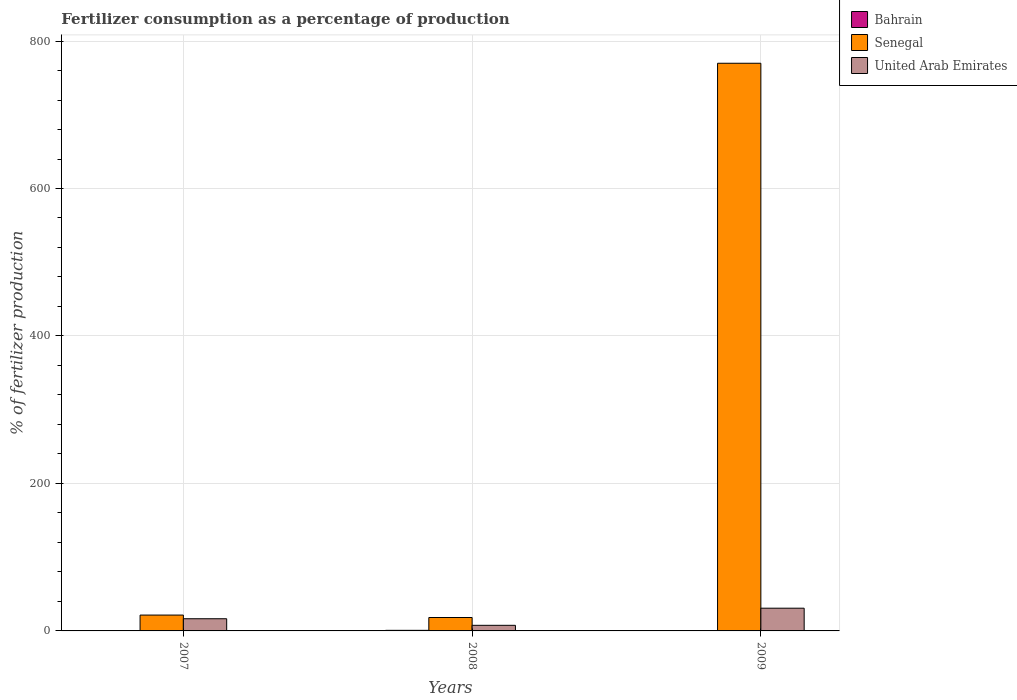Are the number of bars on each tick of the X-axis equal?
Your answer should be compact. Yes. How many bars are there on the 3rd tick from the left?
Your answer should be compact. 3. What is the label of the 2nd group of bars from the left?
Keep it short and to the point. 2008. In how many cases, is the number of bars for a given year not equal to the number of legend labels?
Offer a very short reply. 0. What is the percentage of fertilizers consumed in Senegal in 2009?
Ensure brevity in your answer.  769.84. Across all years, what is the maximum percentage of fertilizers consumed in Bahrain?
Your answer should be very brief. 0.79. Across all years, what is the minimum percentage of fertilizers consumed in Bahrain?
Your answer should be very brief. 0.42. In which year was the percentage of fertilizers consumed in Bahrain maximum?
Your answer should be compact. 2008. In which year was the percentage of fertilizers consumed in United Arab Emirates minimum?
Provide a short and direct response. 2008. What is the total percentage of fertilizers consumed in United Arab Emirates in the graph?
Keep it short and to the point. 54.95. What is the difference between the percentage of fertilizers consumed in United Arab Emirates in 2007 and that in 2008?
Offer a very short reply. 8.92. What is the difference between the percentage of fertilizers consumed in Bahrain in 2008 and the percentage of fertilizers consumed in Senegal in 2009?
Your answer should be compact. -769.06. What is the average percentage of fertilizers consumed in Senegal per year?
Your answer should be compact. 269.84. In the year 2009, what is the difference between the percentage of fertilizers consumed in United Arab Emirates and percentage of fertilizers consumed in Bahrain?
Provide a succinct answer. 30.4. What is the ratio of the percentage of fertilizers consumed in Senegal in 2007 to that in 2009?
Your answer should be very brief. 0.03. Is the percentage of fertilizers consumed in Senegal in 2007 less than that in 2008?
Offer a very short reply. No. What is the difference between the highest and the second highest percentage of fertilizers consumed in United Arab Emirates?
Offer a terse response. 14.31. What is the difference between the highest and the lowest percentage of fertilizers consumed in Senegal?
Your answer should be very brief. 751.66. In how many years, is the percentage of fertilizers consumed in Senegal greater than the average percentage of fertilizers consumed in Senegal taken over all years?
Provide a succinct answer. 1. Is the sum of the percentage of fertilizers consumed in Bahrain in 2007 and 2009 greater than the maximum percentage of fertilizers consumed in United Arab Emirates across all years?
Give a very brief answer. No. What does the 2nd bar from the left in 2009 represents?
Ensure brevity in your answer.  Senegal. What does the 1st bar from the right in 2007 represents?
Keep it short and to the point. United Arab Emirates. Is it the case that in every year, the sum of the percentage of fertilizers consumed in United Arab Emirates and percentage of fertilizers consumed in Bahrain is greater than the percentage of fertilizers consumed in Senegal?
Your response must be concise. No. What is the difference between two consecutive major ticks on the Y-axis?
Your answer should be very brief. 200. Are the values on the major ticks of Y-axis written in scientific E-notation?
Your answer should be very brief. No. How many legend labels are there?
Your answer should be compact. 3. What is the title of the graph?
Offer a very short reply. Fertilizer consumption as a percentage of production. What is the label or title of the X-axis?
Make the answer very short. Years. What is the label or title of the Y-axis?
Provide a succinct answer. % of fertilizer production. What is the % of fertilizer production in Bahrain in 2007?
Your response must be concise. 0.42. What is the % of fertilizer production of Senegal in 2007?
Make the answer very short. 21.5. What is the % of fertilizer production of United Arab Emirates in 2007?
Your answer should be compact. 16.52. What is the % of fertilizer production of Bahrain in 2008?
Make the answer very short. 0.79. What is the % of fertilizer production of Senegal in 2008?
Provide a succinct answer. 18.18. What is the % of fertilizer production in United Arab Emirates in 2008?
Give a very brief answer. 7.6. What is the % of fertilizer production of Bahrain in 2009?
Provide a succinct answer. 0.43. What is the % of fertilizer production in Senegal in 2009?
Offer a terse response. 769.84. What is the % of fertilizer production of United Arab Emirates in 2009?
Offer a very short reply. 30.83. Across all years, what is the maximum % of fertilizer production of Bahrain?
Provide a short and direct response. 0.79. Across all years, what is the maximum % of fertilizer production in Senegal?
Give a very brief answer. 769.84. Across all years, what is the maximum % of fertilizer production of United Arab Emirates?
Offer a terse response. 30.83. Across all years, what is the minimum % of fertilizer production in Bahrain?
Offer a terse response. 0.42. Across all years, what is the minimum % of fertilizer production of Senegal?
Provide a short and direct response. 18.18. Across all years, what is the minimum % of fertilizer production in United Arab Emirates?
Your answer should be compact. 7.6. What is the total % of fertilizer production in Bahrain in the graph?
Make the answer very short. 1.63. What is the total % of fertilizer production of Senegal in the graph?
Provide a succinct answer. 809.53. What is the total % of fertilizer production of United Arab Emirates in the graph?
Your answer should be compact. 54.95. What is the difference between the % of fertilizer production in Bahrain in 2007 and that in 2008?
Provide a short and direct response. -0.37. What is the difference between the % of fertilizer production in Senegal in 2007 and that in 2008?
Offer a very short reply. 3.32. What is the difference between the % of fertilizer production of United Arab Emirates in 2007 and that in 2008?
Keep it short and to the point. 8.92. What is the difference between the % of fertilizer production in Bahrain in 2007 and that in 2009?
Ensure brevity in your answer.  -0.01. What is the difference between the % of fertilizer production in Senegal in 2007 and that in 2009?
Offer a terse response. -748.34. What is the difference between the % of fertilizer production in United Arab Emirates in 2007 and that in 2009?
Your answer should be very brief. -14.31. What is the difference between the % of fertilizer production of Bahrain in 2008 and that in 2009?
Your answer should be very brief. 0.36. What is the difference between the % of fertilizer production of Senegal in 2008 and that in 2009?
Provide a succinct answer. -751.66. What is the difference between the % of fertilizer production of United Arab Emirates in 2008 and that in 2009?
Offer a terse response. -23.23. What is the difference between the % of fertilizer production in Bahrain in 2007 and the % of fertilizer production in Senegal in 2008?
Provide a succinct answer. -17.77. What is the difference between the % of fertilizer production of Bahrain in 2007 and the % of fertilizer production of United Arab Emirates in 2008?
Your answer should be compact. -7.18. What is the difference between the % of fertilizer production in Senegal in 2007 and the % of fertilizer production in United Arab Emirates in 2008?
Make the answer very short. 13.9. What is the difference between the % of fertilizer production in Bahrain in 2007 and the % of fertilizer production in Senegal in 2009?
Your response must be concise. -769.43. What is the difference between the % of fertilizer production in Bahrain in 2007 and the % of fertilizer production in United Arab Emirates in 2009?
Your answer should be very brief. -30.41. What is the difference between the % of fertilizer production in Senegal in 2007 and the % of fertilizer production in United Arab Emirates in 2009?
Provide a short and direct response. -9.33. What is the difference between the % of fertilizer production in Bahrain in 2008 and the % of fertilizer production in Senegal in 2009?
Ensure brevity in your answer.  -769.06. What is the difference between the % of fertilizer production in Bahrain in 2008 and the % of fertilizer production in United Arab Emirates in 2009?
Ensure brevity in your answer.  -30.04. What is the difference between the % of fertilizer production in Senegal in 2008 and the % of fertilizer production in United Arab Emirates in 2009?
Your answer should be very brief. -12.65. What is the average % of fertilizer production of Bahrain per year?
Provide a succinct answer. 0.54. What is the average % of fertilizer production of Senegal per year?
Offer a very short reply. 269.84. What is the average % of fertilizer production in United Arab Emirates per year?
Keep it short and to the point. 18.32. In the year 2007, what is the difference between the % of fertilizer production of Bahrain and % of fertilizer production of Senegal?
Ensure brevity in your answer.  -21.09. In the year 2007, what is the difference between the % of fertilizer production in Bahrain and % of fertilizer production in United Arab Emirates?
Your response must be concise. -16.1. In the year 2007, what is the difference between the % of fertilizer production in Senegal and % of fertilizer production in United Arab Emirates?
Keep it short and to the point. 4.98. In the year 2008, what is the difference between the % of fertilizer production of Bahrain and % of fertilizer production of Senegal?
Keep it short and to the point. -17.39. In the year 2008, what is the difference between the % of fertilizer production of Bahrain and % of fertilizer production of United Arab Emirates?
Provide a short and direct response. -6.81. In the year 2008, what is the difference between the % of fertilizer production in Senegal and % of fertilizer production in United Arab Emirates?
Offer a terse response. 10.58. In the year 2009, what is the difference between the % of fertilizer production in Bahrain and % of fertilizer production in Senegal?
Provide a short and direct response. -769.41. In the year 2009, what is the difference between the % of fertilizer production of Bahrain and % of fertilizer production of United Arab Emirates?
Provide a succinct answer. -30.4. In the year 2009, what is the difference between the % of fertilizer production in Senegal and % of fertilizer production in United Arab Emirates?
Offer a very short reply. 739.01. What is the ratio of the % of fertilizer production in Bahrain in 2007 to that in 2008?
Provide a succinct answer. 0.53. What is the ratio of the % of fertilizer production in Senegal in 2007 to that in 2008?
Keep it short and to the point. 1.18. What is the ratio of the % of fertilizer production in United Arab Emirates in 2007 to that in 2008?
Give a very brief answer. 2.17. What is the ratio of the % of fertilizer production of Senegal in 2007 to that in 2009?
Offer a terse response. 0.03. What is the ratio of the % of fertilizer production of United Arab Emirates in 2007 to that in 2009?
Your answer should be very brief. 0.54. What is the ratio of the % of fertilizer production in Bahrain in 2008 to that in 2009?
Give a very brief answer. 1.84. What is the ratio of the % of fertilizer production of Senegal in 2008 to that in 2009?
Offer a terse response. 0.02. What is the ratio of the % of fertilizer production in United Arab Emirates in 2008 to that in 2009?
Ensure brevity in your answer.  0.25. What is the difference between the highest and the second highest % of fertilizer production in Bahrain?
Offer a very short reply. 0.36. What is the difference between the highest and the second highest % of fertilizer production in Senegal?
Provide a short and direct response. 748.34. What is the difference between the highest and the second highest % of fertilizer production of United Arab Emirates?
Provide a succinct answer. 14.31. What is the difference between the highest and the lowest % of fertilizer production of Bahrain?
Your response must be concise. 0.37. What is the difference between the highest and the lowest % of fertilizer production of Senegal?
Provide a succinct answer. 751.66. What is the difference between the highest and the lowest % of fertilizer production of United Arab Emirates?
Your answer should be very brief. 23.23. 